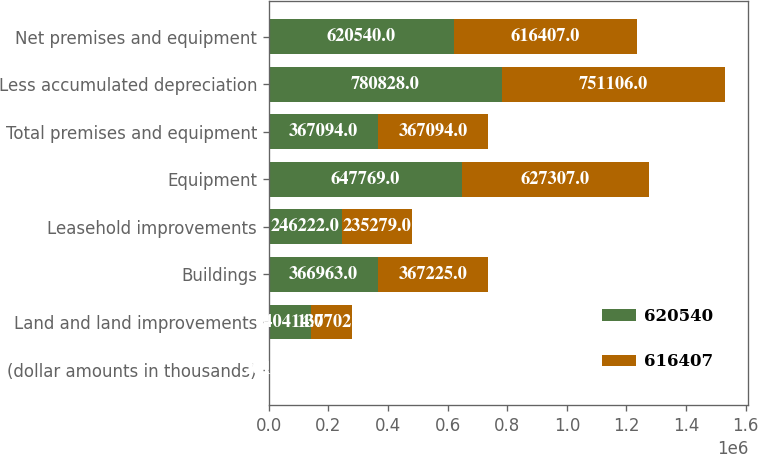Convert chart to OTSL. <chart><loc_0><loc_0><loc_500><loc_500><stacked_bar_chart><ecel><fcel>(dollar amounts in thousands)<fcel>Land and land improvements<fcel>Buildings<fcel>Leasehold improvements<fcel>Equipment<fcel>Total premises and equipment<fcel>Less accumulated depreciation<fcel>Net premises and equipment<nl><fcel>620540<fcel>2015<fcel>140414<fcel>366963<fcel>246222<fcel>647769<fcel>367094<fcel>780828<fcel>620540<nl><fcel>616407<fcel>2014<fcel>137702<fcel>367225<fcel>235279<fcel>627307<fcel>367094<fcel>751106<fcel>616407<nl></chart> 